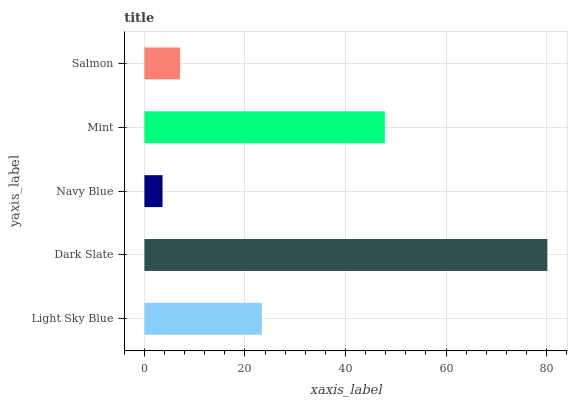Is Navy Blue the minimum?
Answer yes or no. Yes. Is Dark Slate the maximum?
Answer yes or no. Yes. Is Dark Slate the minimum?
Answer yes or no. No. Is Navy Blue the maximum?
Answer yes or no. No. Is Dark Slate greater than Navy Blue?
Answer yes or no. Yes. Is Navy Blue less than Dark Slate?
Answer yes or no. Yes. Is Navy Blue greater than Dark Slate?
Answer yes or no. No. Is Dark Slate less than Navy Blue?
Answer yes or no. No. Is Light Sky Blue the high median?
Answer yes or no. Yes. Is Light Sky Blue the low median?
Answer yes or no. Yes. Is Dark Slate the high median?
Answer yes or no. No. Is Dark Slate the low median?
Answer yes or no. No. 